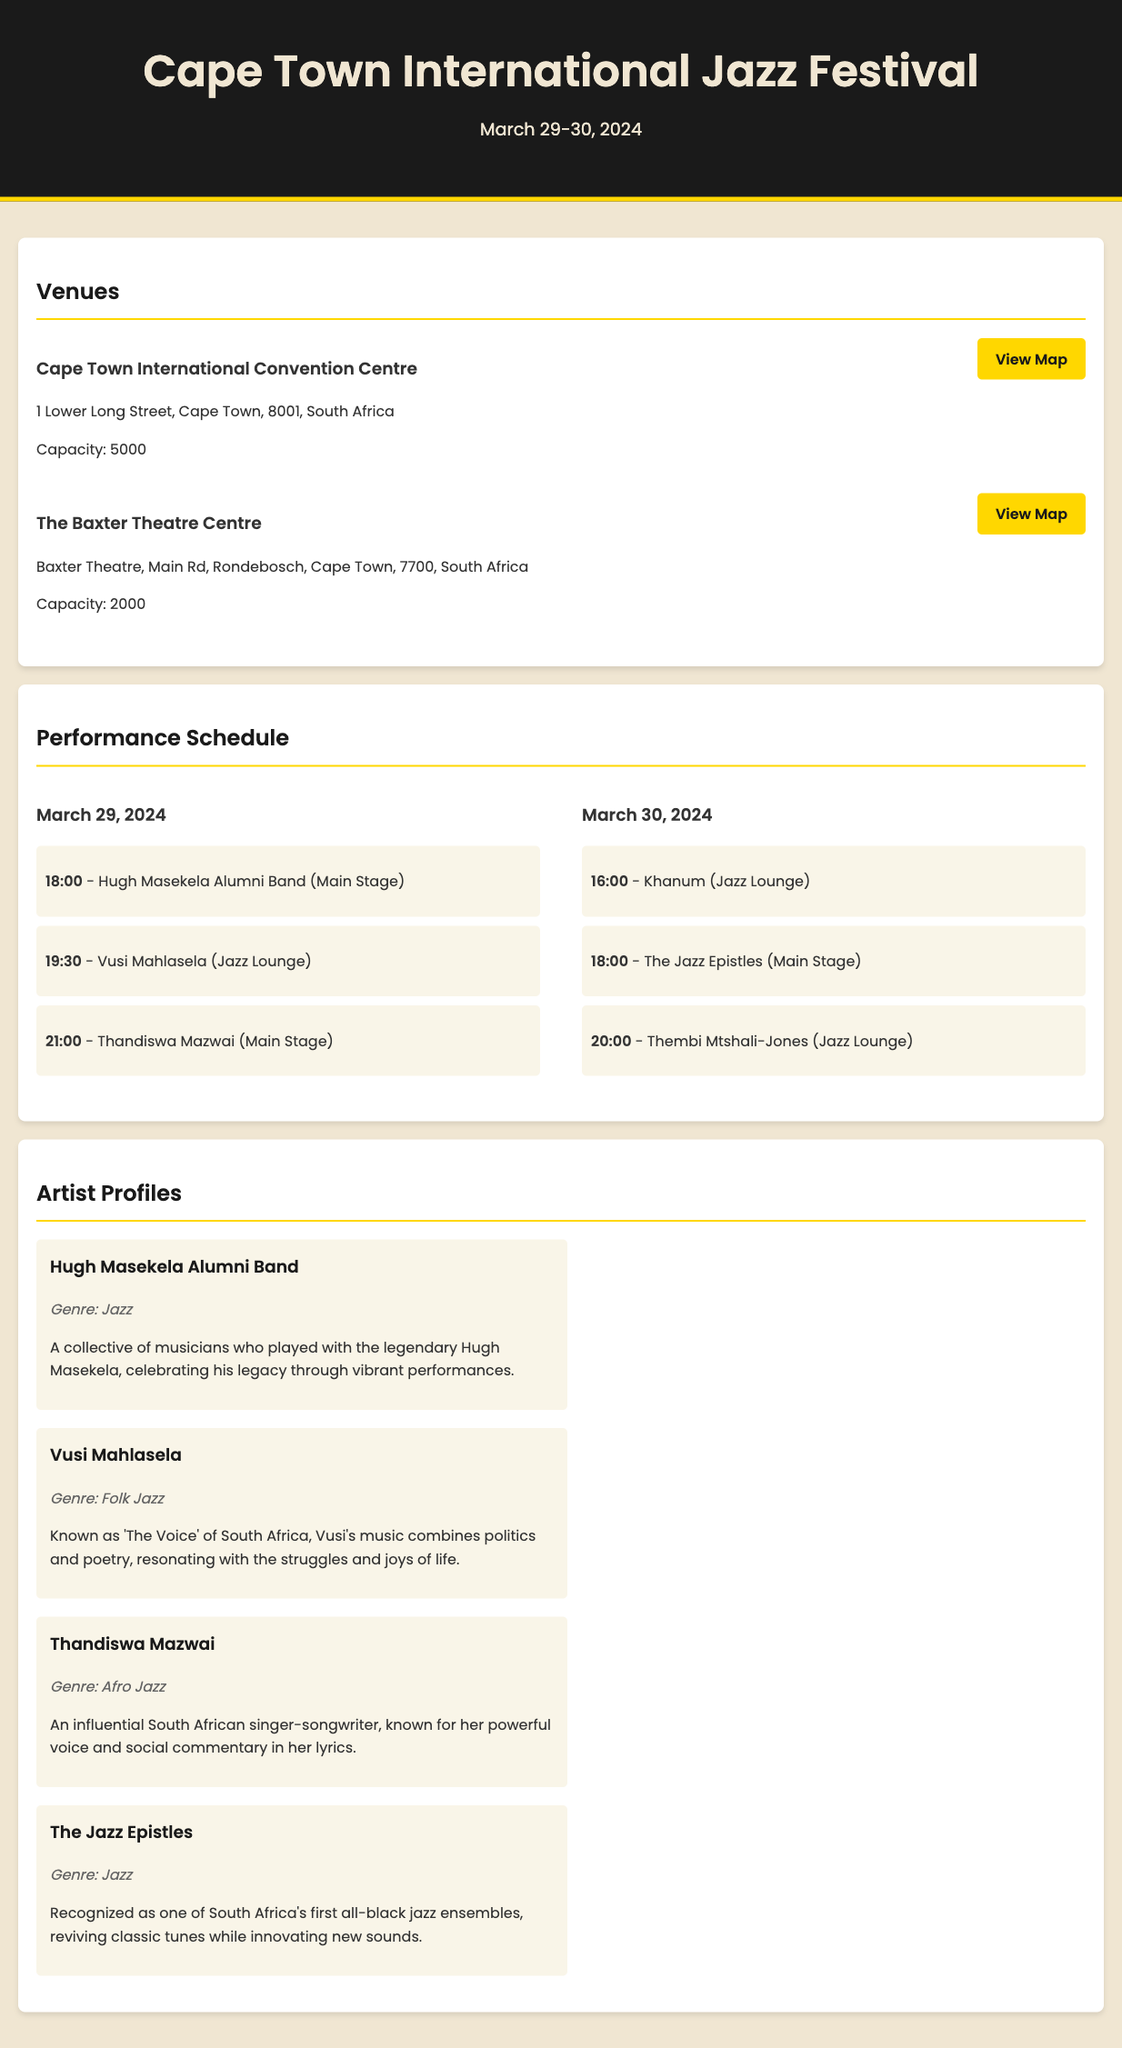what are the festival dates? The festival dates are listed prominently in the header of the document.
Answer: March 29-30, 2024 what is the capacity of the Cape Town International Convention Centre? The capacity is mentioned in the venue section for the Cape Town International Convention Centre.
Answer: 5000 who is performing at 19:30 on March 29, 2024? The performance schedule lists the artists alongside their respective times and dates.
Answer: Vusi Mahlasela what is the genre of Thandiswa Mazwai? Each artist profile includes the genre associated with them.
Answer: Afro Jazz which venue has a lower capacity, Baxter Theatre or Cape Town International Convention Centre? The capacities of both venues are provided, allowing for comparison.
Answer: The Baxter Theatre Centre what type of music does Vusi Mahlasela combine in his performances? The artist profiles describe the style and themes present in Vusi Mahlasela's music.
Answer: Politics and poetry how many performances are scheduled for March 30, 2024? The performance schedule outlines the number of performances for each day of the festival.
Answer: 3 who were the Jazz Epistles? The artist profiles provide background information on the Jazz Epistles.
Answer: South Africa's first all-black jazz ensembles what is the address of The Baxter Theatre Centre? The venue information provides the full address of The Baxter Theatre Centre.
Answer: Baxter Theatre, Main Rd, Rondebosch, Cape Town, 7700, South Africa 